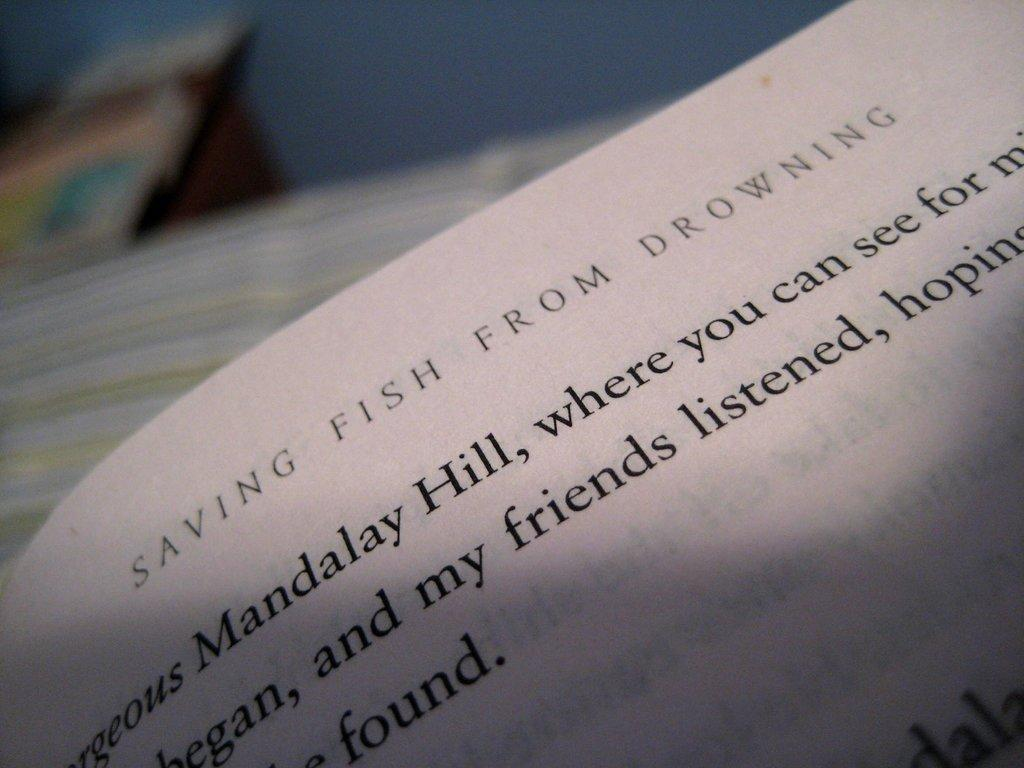<image>
Share a concise interpretation of the image provided. A book is open to a chapter about Saving Fish from Drowning. 